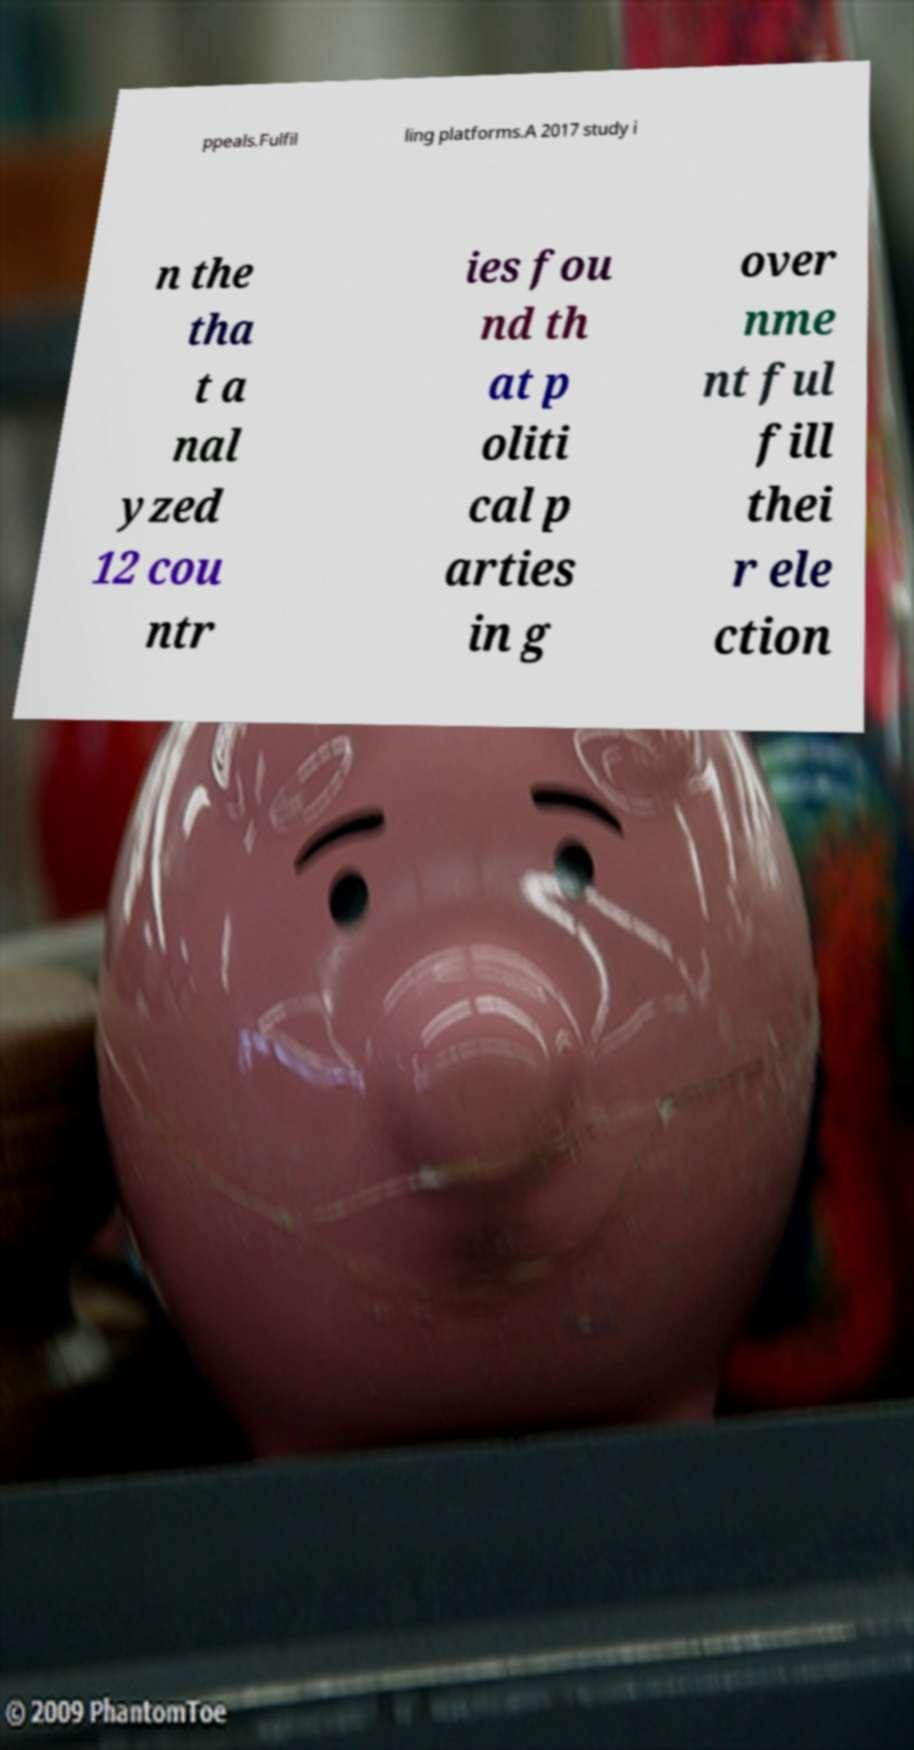Could you extract and type out the text from this image? ppeals.Fulfil ling platforms.A 2017 study i n the tha t a nal yzed 12 cou ntr ies fou nd th at p oliti cal p arties in g over nme nt ful fill thei r ele ction 